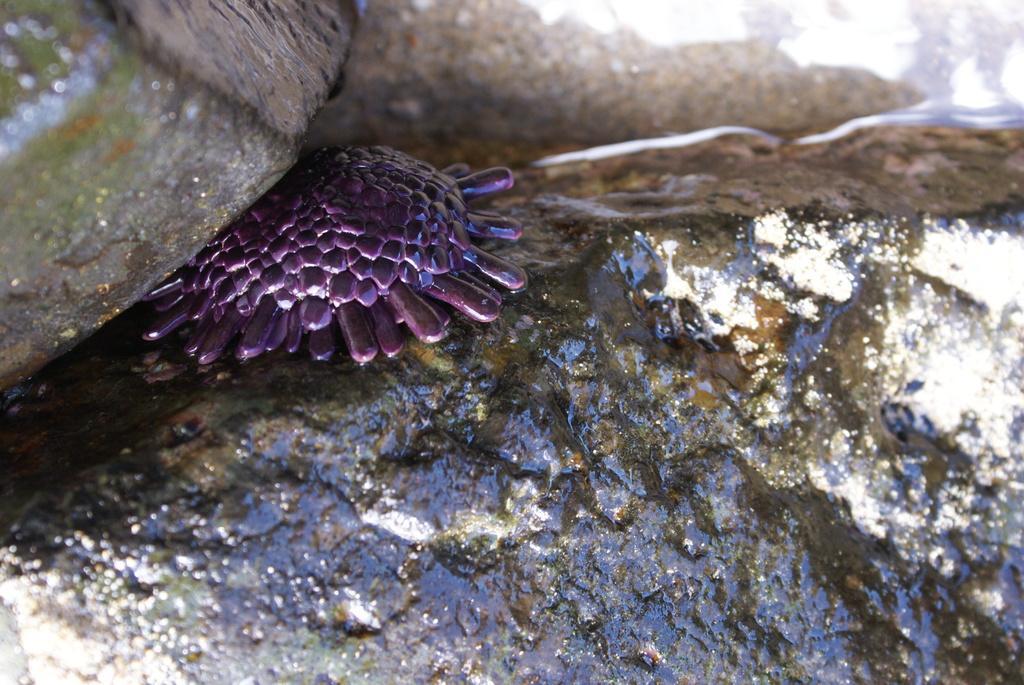How would you summarize this image in a sentence or two? In this image it seems to be a plastic toy under the rock. 